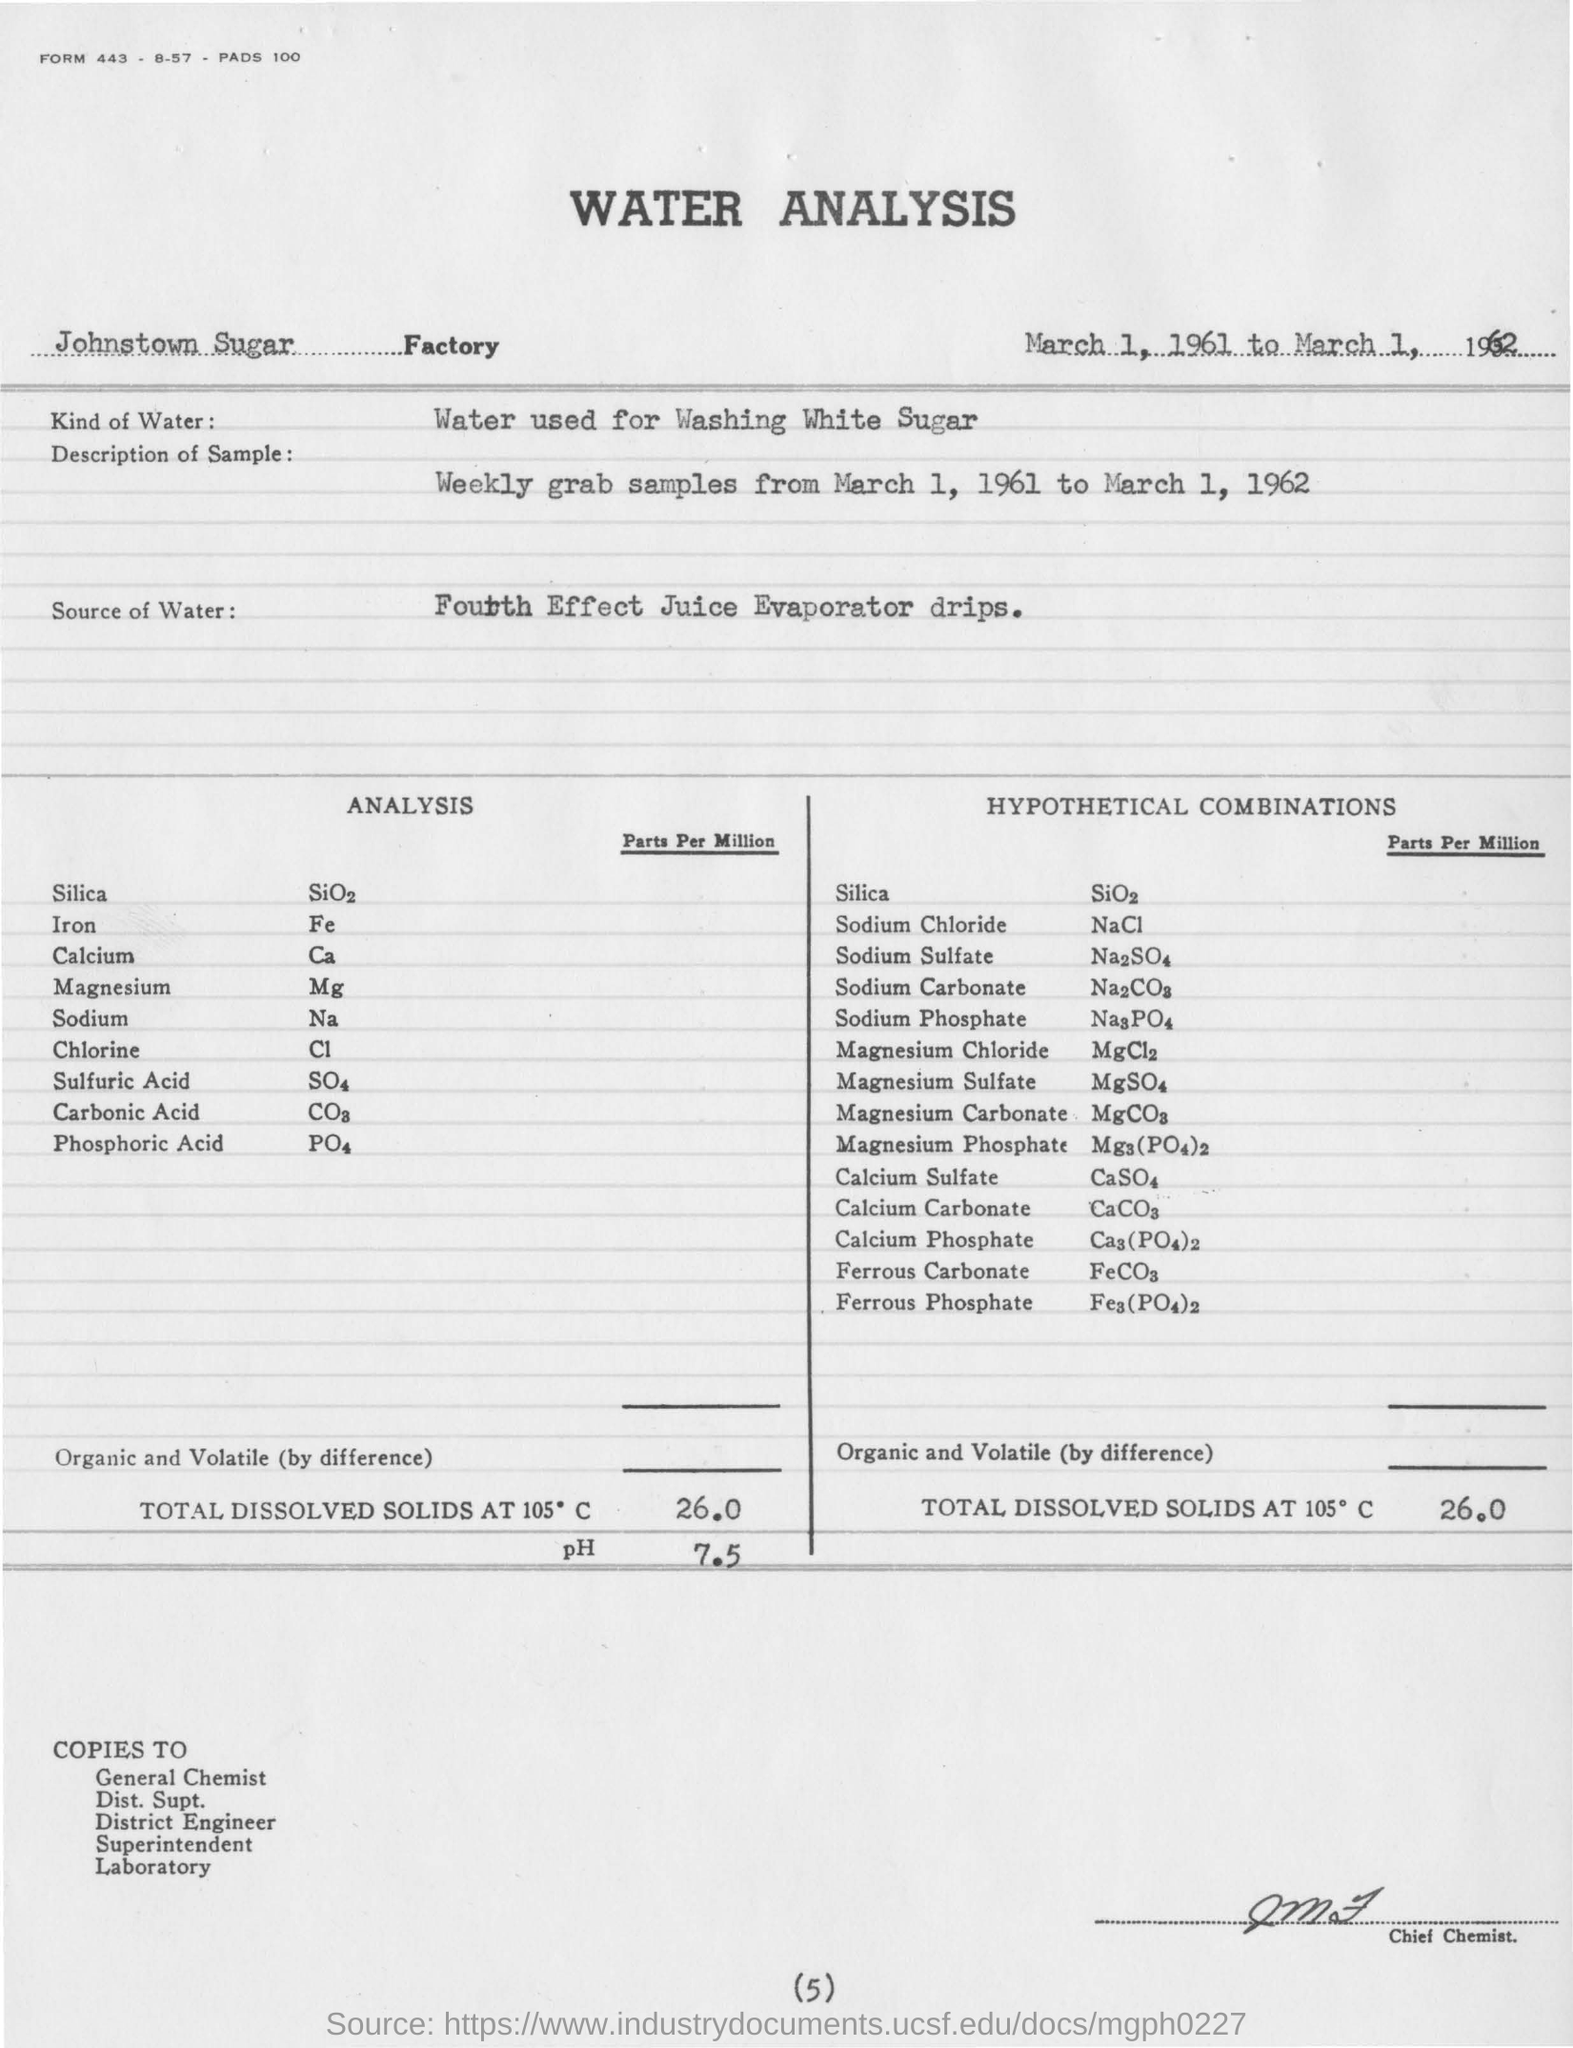Mention a couple of crucial points in this snapshot. The Johnstown Sugar Factory is mentioned. The water used in the analysis is the same water used for washing white sugar. The analysis was conducted from March 1, 1961 to March 1, 1962. The source of water is Fourth Effect Juice Evaporator drips. 